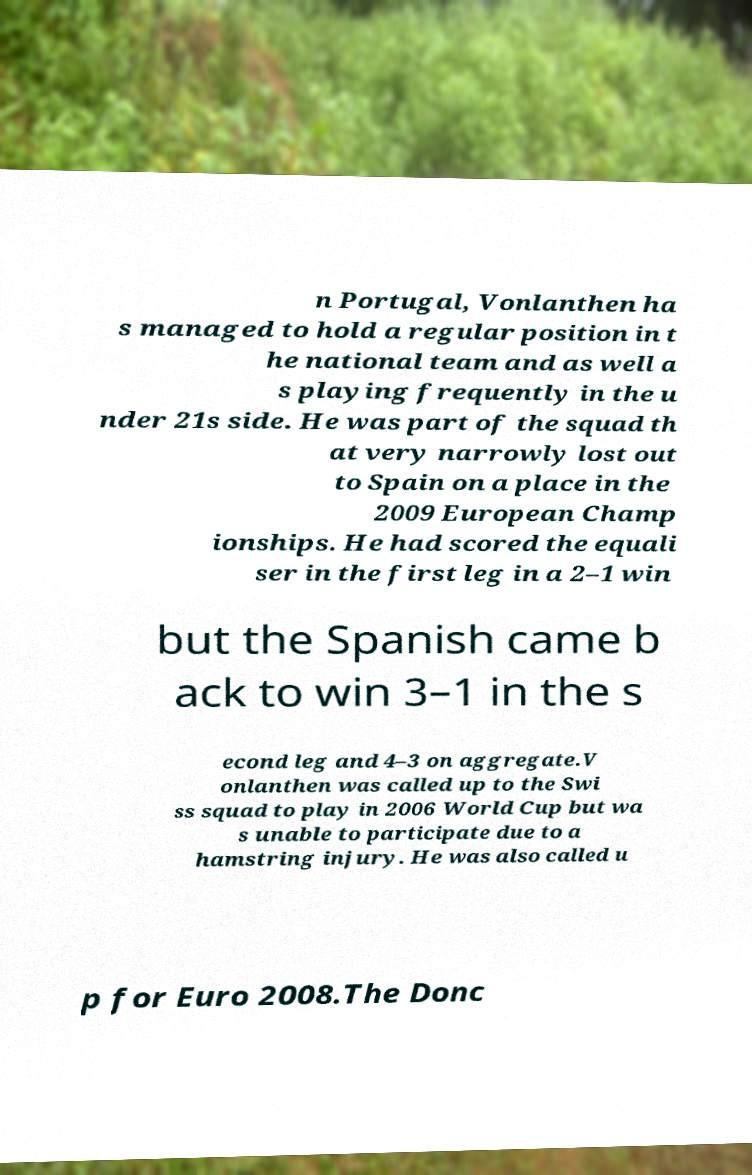Could you assist in decoding the text presented in this image and type it out clearly? n Portugal, Vonlanthen ha s managed to hold a regular position in t he national team and as well a s playing frequently in the u nder 21s side. He was part of the squad th at very narrowly lost out to Spain on a place in the 2009 European Champ ionships. He had scored the equali ser in the first leg in a 2–1 win but the Spanish came b ack to win 3–1 in the s econd leg and 4–3 on aggregate.V onlanthen was called up to the Swi ss squad to play in 2006 World Cup but wa s unable to participate due to a hamstring injury. He was also called u p for Euro 2008.The Donc 